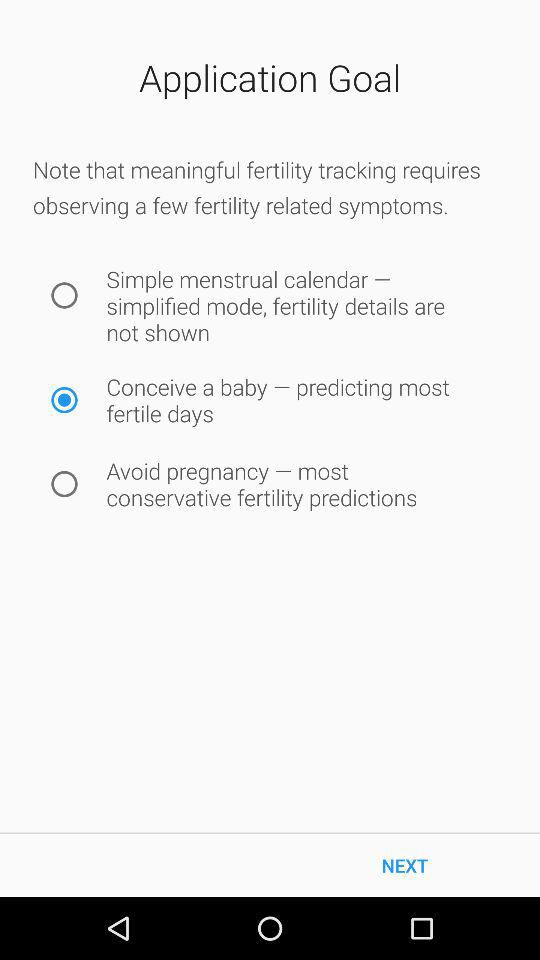How many fertility tracking modes are there?
Answer the question using a single word or phrase. 3 